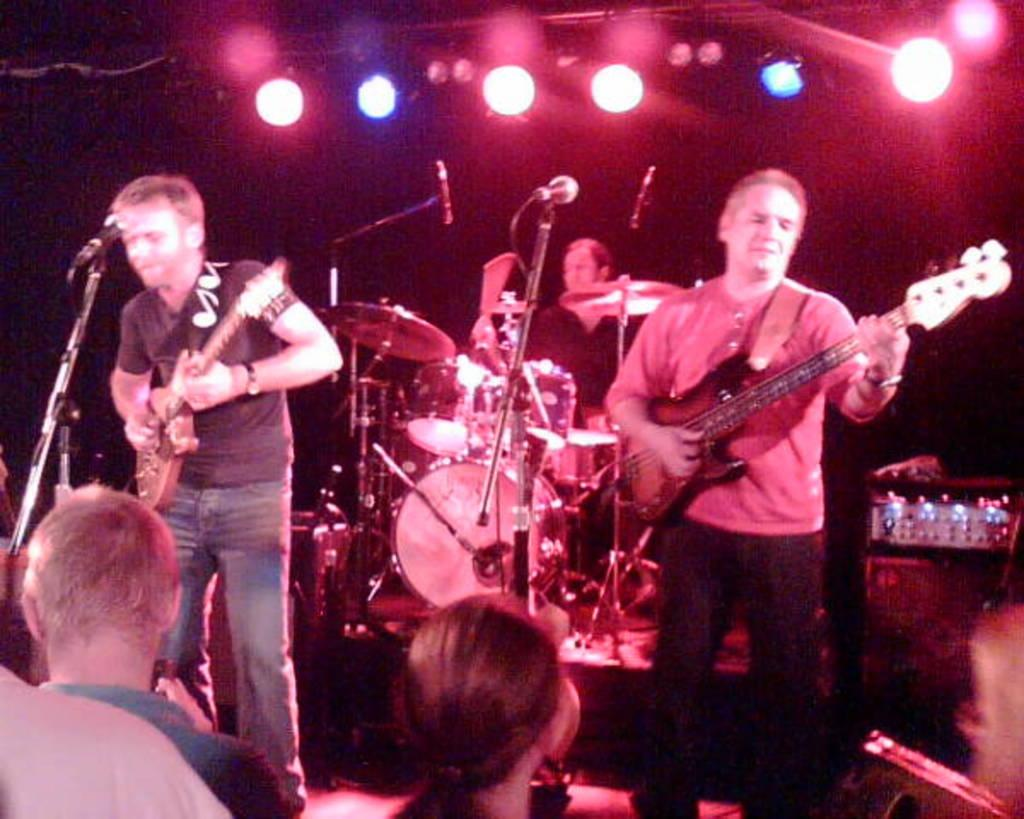How many people are playing musical instruments in the image? There are three people in the image, and each person is playing a different musical instrument. What are the people in front of the musicians doing? The provided facts do not mention any people in front of the musicians, so we cannot answer this question definitively. What can be seen above the musicians in the image? There are lines above the musicians in the image. What type of machine is being protested against in the image? There is no machine or protest present in the image; it features three people playing musical instruments. 